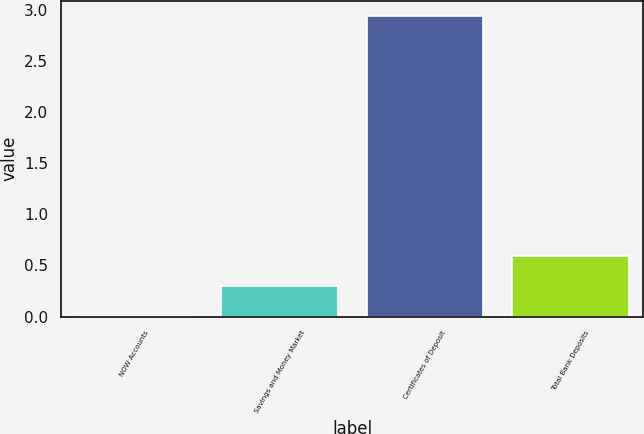Convert chart. <chart><loc_0><loc_0><loc_500><loc_500><bar_chart><fcel>NOW Accounts<fcel>Savings and Money Market<fcel>Certificates of Deposit<fcel>Total Bank Deposits<nl><fcel>0.01<fcel>0.3<fcel>2.94<fcel>0.59<nl></chart> 